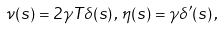<formula> <loc_0><loc_0><loc_500><loc_500>\nu ( s ) = 2 \gamma T \delta ( s ) \, , \, \eta ( s ) = \gamma \delta ^ { \prime } ( s ) \, ,</formula> 